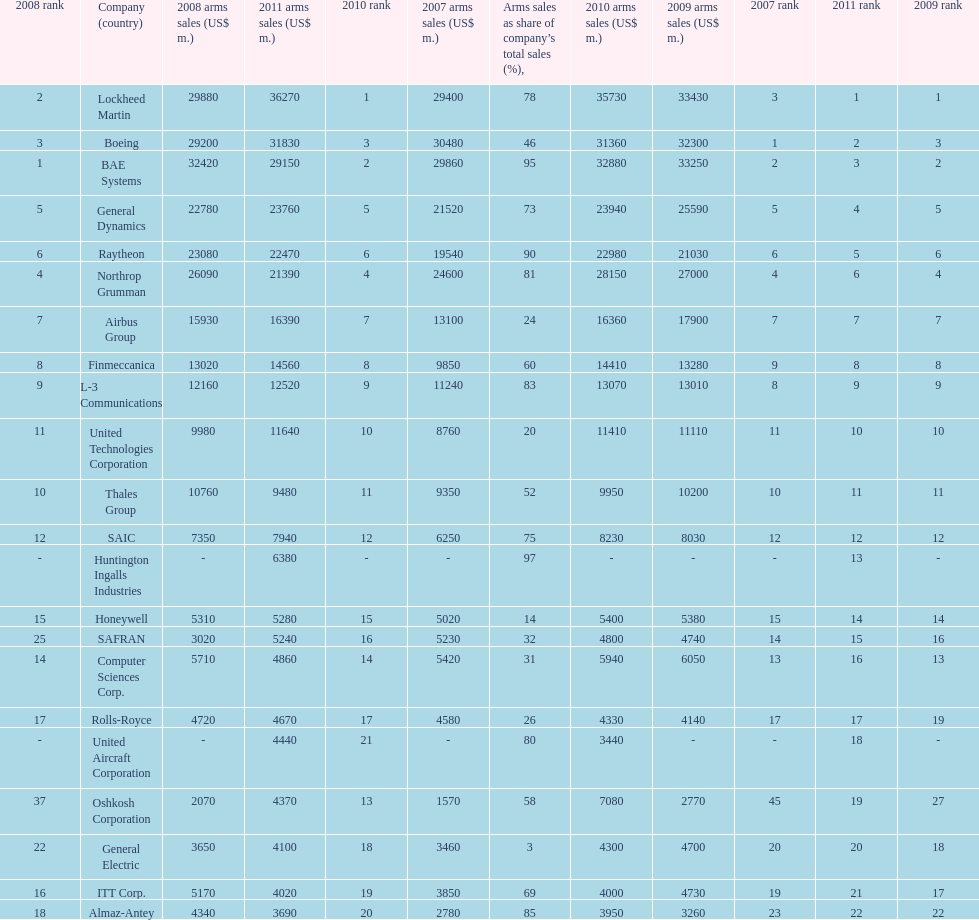How many companies are under the united states? 14. 